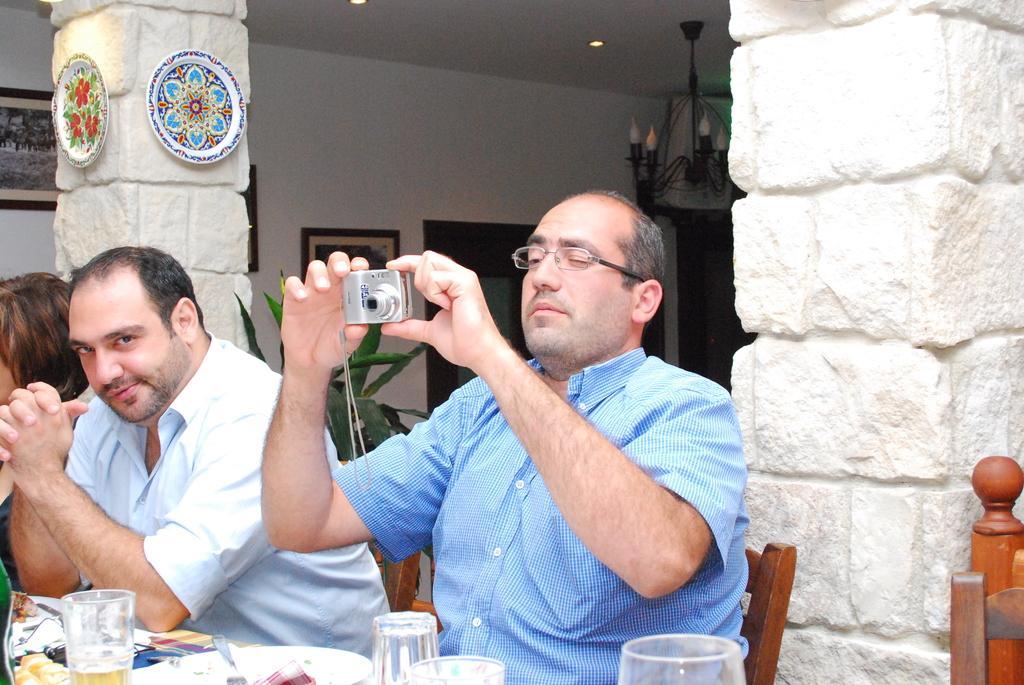Describe this image in one or two sentences. In this image In the middle there is a man he is sitting he wear shirt and spectacles he hold a camera. On the left there is a man and woman. At the bottom there is a table on that there is a plate and glass. 